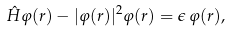Convert formula to latex. <formula><loc_0><loc_0><loc_500><loc_500>\hat { H } \varphi ( { r } ) - | \varphi ( { r } ) | ^ { 2 } \varphi ( { r } ) = \epsilon \, \varphi ( { r } ) ,</formula> 